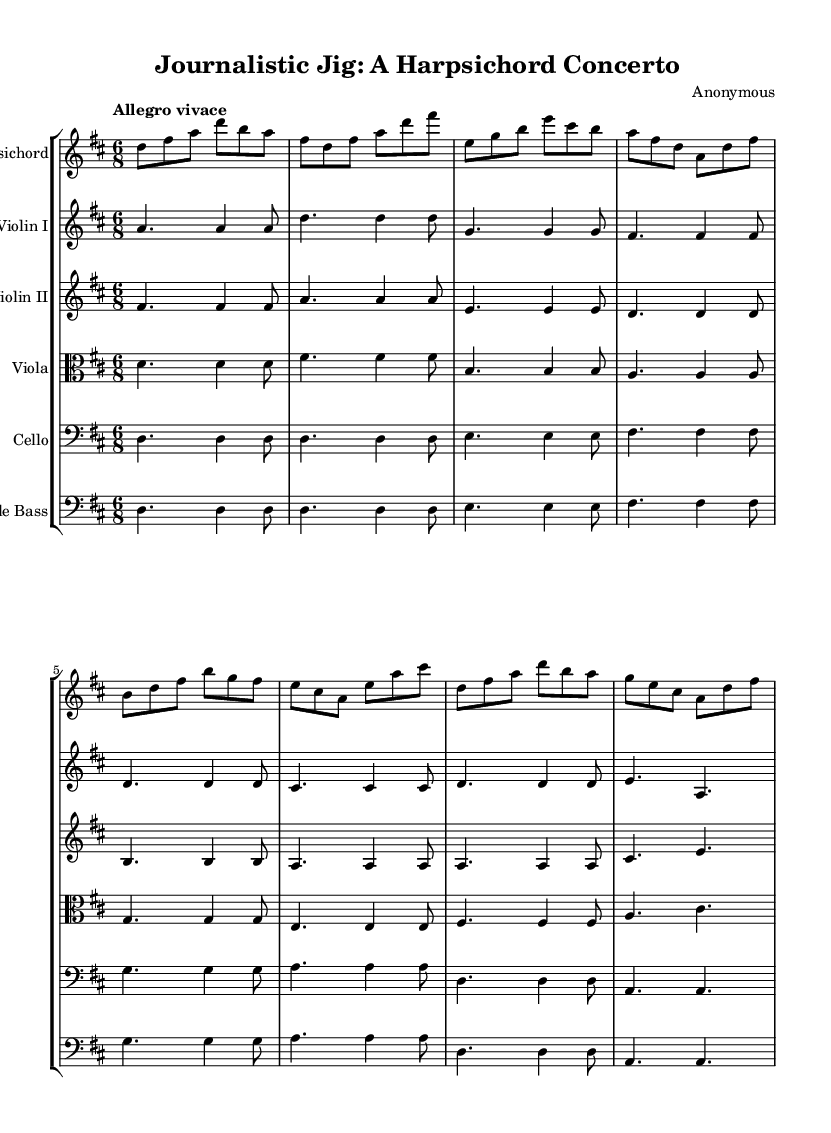What is the key signature of this music? The key signature has two sharps, which indicates that the piece is in D major. In the key signature section of the sheet music, we see two sharp symbols preceding the staff lines.
Answer: D major What is the time signature of this music? The time signature is 6/8, which is indicated at the beginning of the music. The two numbers show that there are six beats in a measure and the eighth note gets the beat.
Answer: 6/8 What is the tempo marking of this music? The tempo marking is "Allegro vivace," which conveys a fast and lively pace. This is explicitly stated above the staff at the beginning of the piece.
Answer: Allegro vivace How many instruments are in this concerto? There are six instruments listed in the score: Harpsichord, Violin I, Violin II, Viola, Cello, and Double Bass. Each instrument has its own staff indicating that they all play together in the concerto.
Answer: Six instruments Which instrument plays the opening melody? The Harpsichord plays the opening melody, as indicated by its corresponding staff at the top of the score, where the first notes are written.
Answer: Harpsichord What is the rhythmic pattern primarily used in the Harpsichord part? The Harpsichord part primarily uses a consistent eighth-note rhythmic pattern, creating a lively and energetic feel throughout the piece. A quick glance at the Harpsichord staff reveals recurring eighth notes.
Answer: Eighth notes What type of movement is characteristic of the Baroque concerto found in this piece? This piece is characterized by a dance-like movement, reflected in the 6/8 time signature and the lively tempo, typical of Baroque music that often features dance forms.
Answer: Dance-like movement 